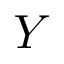Convert formula to latex. <formula><loc_0><loc_0><loc_500><loc_500>Y</formula> 